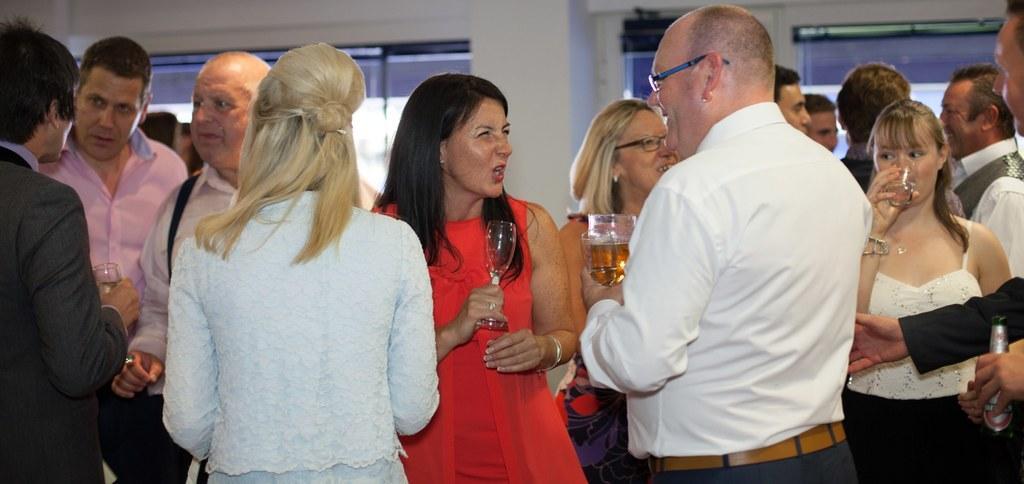Describe this image in one or two sentences. This picture is clicked inside. In the foreground we can see the group of people holding glasses of drinks and standing. On the right corner there is a person holding a bottle and standing. In the background we can see the windows, pillar and the wall and group of persons. 